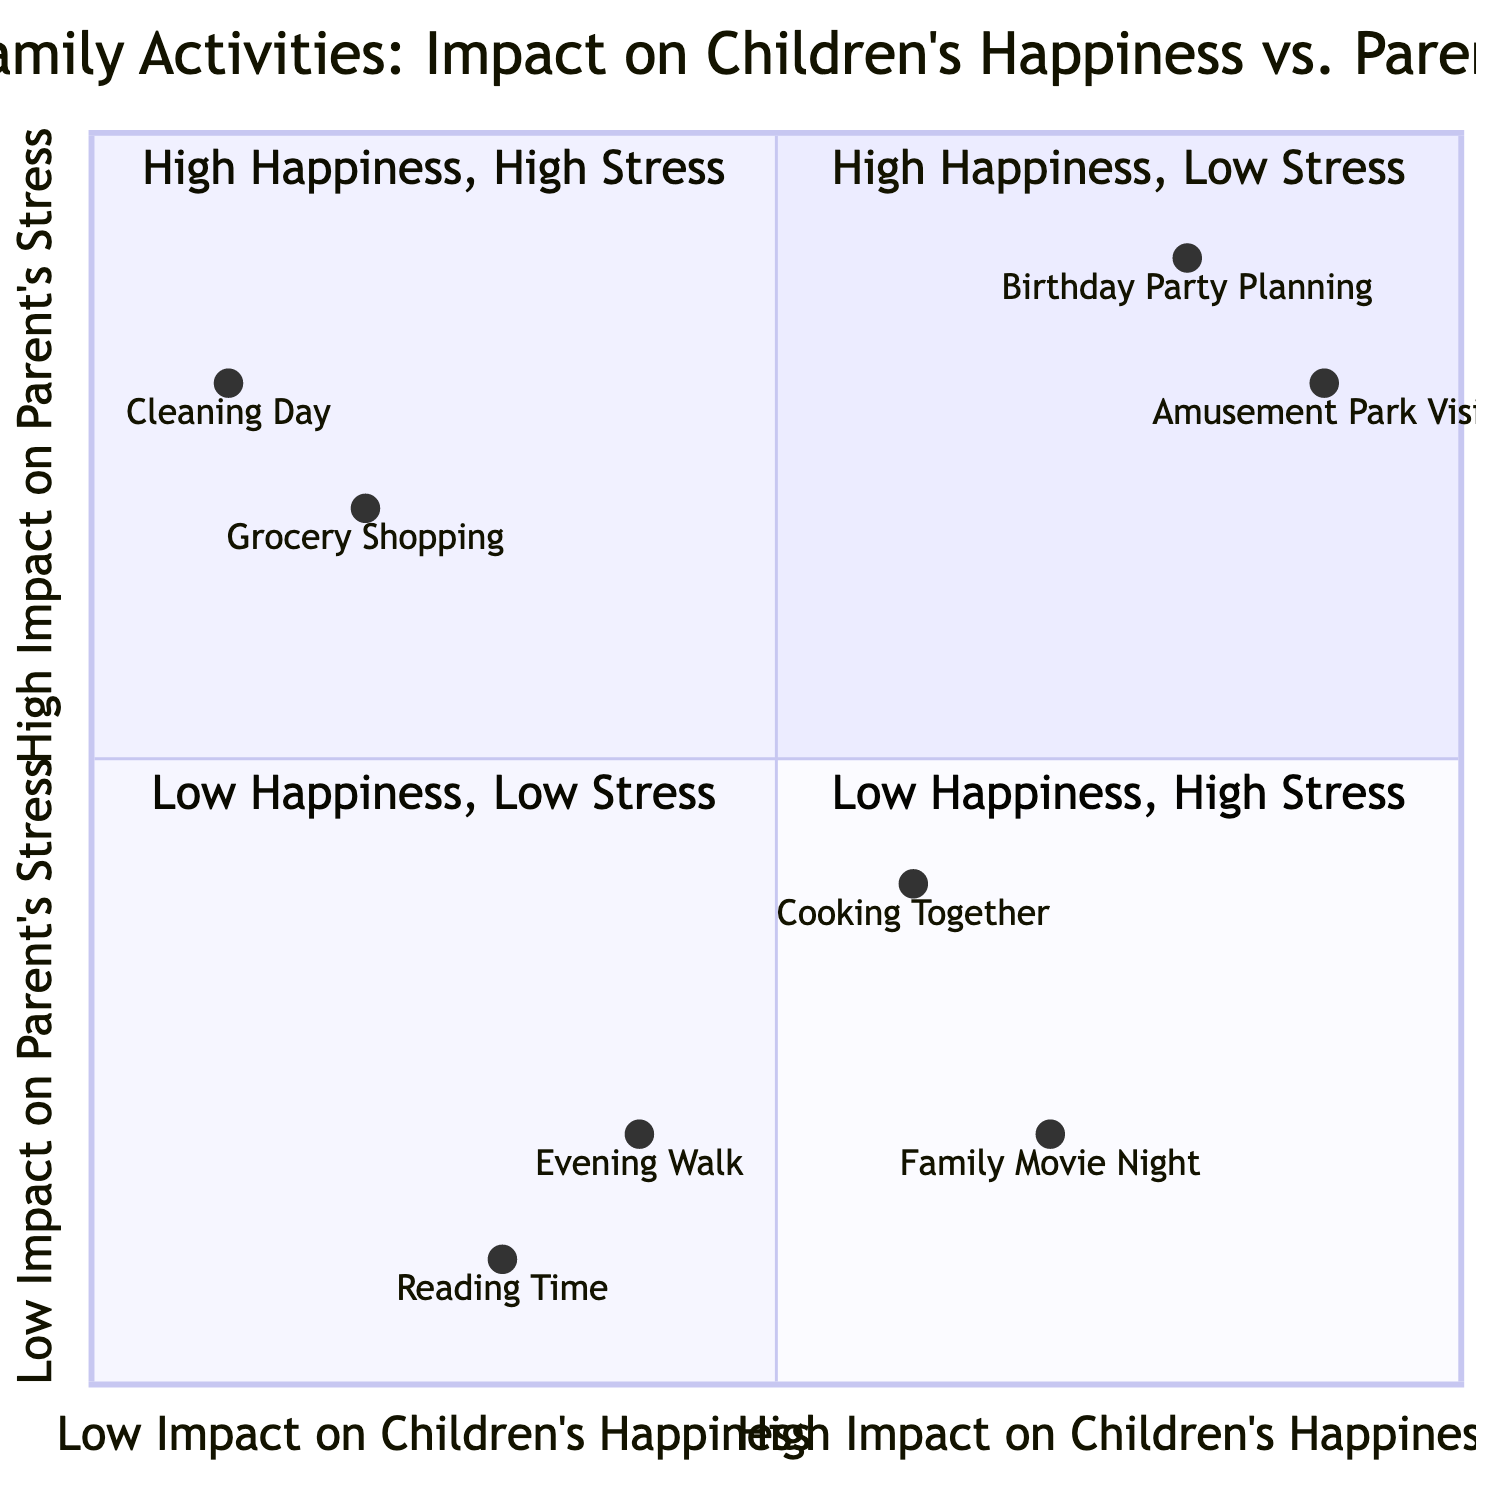What activities are in the "High Happiness, Low Stress" quadrant? The "High Happiness, Low Stress" quadrant contains the activities "Family Movie Night" and "Cooking Together" which are listed under that quadrant in the diagram.
Answer: Family Movie Night, Cooking Together How many activities are present in the "Low Happiness, High Stress" quadrant? There are two activities in the "Low Happiness, High Stress" quadrant: "Grocery Shopping" and "Cleaning Day." Therefore, counting these gives a total of two activities present.
Answer: 2 Which activity has the highest impact on children's happiness? The activity with the highest impact on children's happiness is "Amusement Park Visit," which is located in the "High Happiness, High Stress" quadrant. Its impact value is the highest among all activities shown in the diagram.
Answer: Amusement Park Visit What is the stress level impact of the "Evening Walk"? The "Evening Walk" activity has an impact on parent's stress levels that is described in the "Low Happiness, Low Stress" quadrant, specifically a value of 0.2 indicating a low stress impact.
Answer: 0.2 Which quadrant contains both high happiness and high stress activities? The quadrant that contains both high happiness and high stress activities is named "High Happiness, High Stress." This quadrant includes activities like "Amusement Park Visit" and "Birthday Party Planning."
Answer: High Happiness, High Stress What is the relationship between "Grocery Shopping" and "Cleaning Day"? Both "Grocery Shopping" and "Cleaning Day" are located in the same quadrant, which is "Low Happiness, High Stress," indicating they share the characteristic of not providing much happiness while increasing stress for parents.
Answer: Same quadrant Which activity has a lower impact on children's happiness: "Reading Time" or "Family Movie Night"? "Reading Time" has a lower impact on children's happiness (0.3) compared to "Family Movie Night" (0.7), which is located in the "High Happiness, Low Stress" quadrant.
Answer: Reading Time What is the combined total of activities in the "Low Happiness, Low Stress" and "Low Happiness, High Stress" quadrants? In the "Low Happiness, Low Stress" quadrant there are 2 activities ("Reading Time" and "Evening Walk") and in the "Low Happiness, High Stress" quadrant there are also 2 activities ("Grocery Shopping" and "Cleaning Day"), giving a combined total of 4 activities.
Answer: 4 